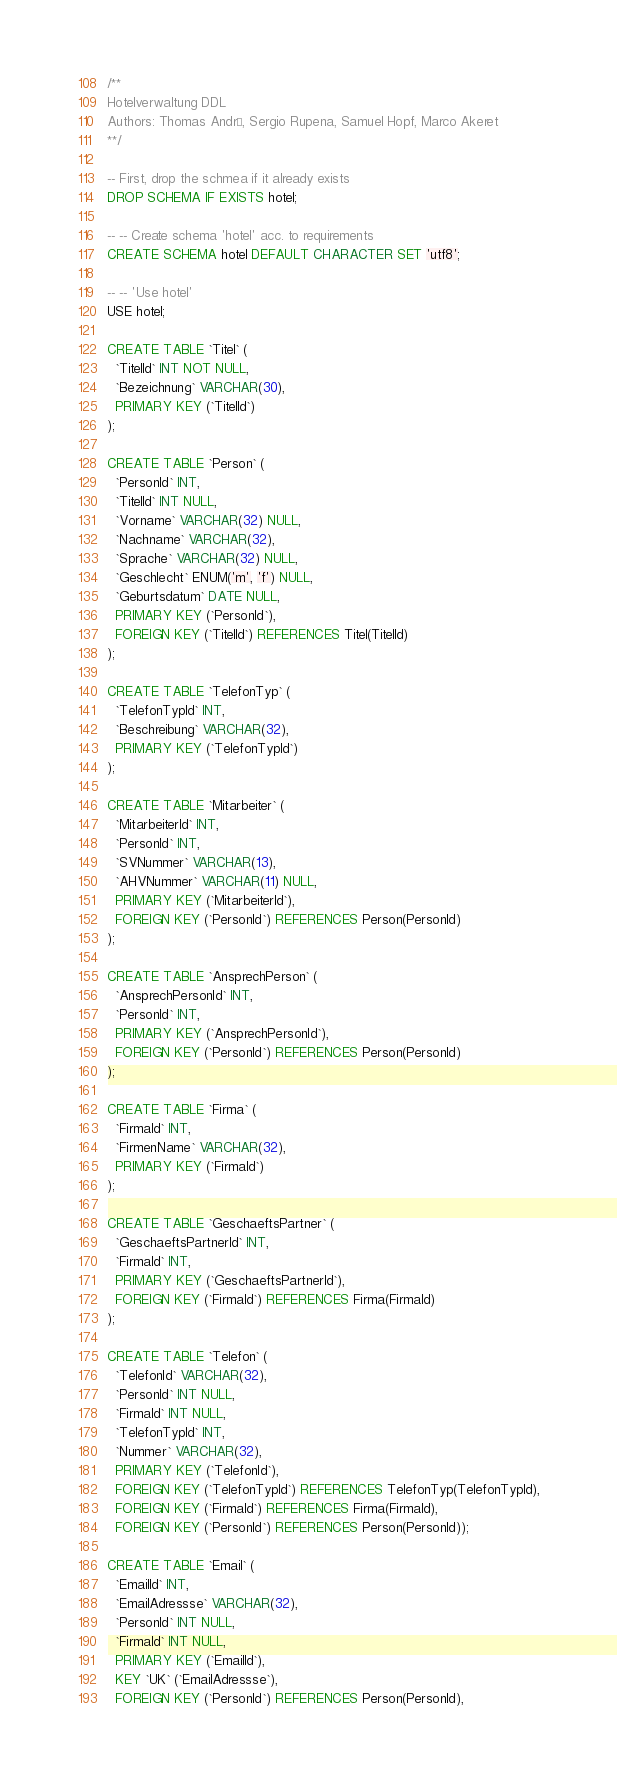<code> <loc_0><loc_0><loc_500><loc_500><_SQL_>/**
Hotelverwaltung DDL
Authors: Thomas André, Sergio Rupena, Samuel Hopf, Marco Akeret
**/

-- First, drop the schmea if it already exists
DROP SCHEMA IF EXISTS hotel;

-- -- Create schema 'hotel' acc. to requirements
CREATE SCHEMA hotel DEFAULT CHARACTER SET 'utf8';

-- -- 'Use hotel'
USE hotel;

CREATE TABLE `Titel` (
  `TitelId` INT NOT NULL,
  `Bezeichnung` VARCHAR(30),
  PRIMARY KEY (`TitelId`)
);

CREATE TABLE `Person` (
  `PersonId` INT,
  `TitelId` INT NULL,
  `Vorname` VARCHAR(32) NULL,
  `Nachname` VARCHAR(32),
  `Sprache` VARCHAR(32) NULL,
  `Geschlecht` ENUM('m', 'f') NULL,
  `Geburtsdatum` DATE NULL,
  PRIMARY KEY (`PersonId`),
  FOREIGN KEY (`TitelId`) REFERENCES Titel(TitelId) 
);

CREATE TABLE `TelefonTyp` (
  `TelefonTypId` INT,
  `Beschreibung` VARCHAR(32),
  PRIMARY KEY (`TelefonTypId`)
);

CREATE TABLE `Mitarbeiter` (
  `MitarbeiterId` INT,
  `PersonId` INT,
  `SVNummer` VARCHAR(13),
  `AHVNummer` VARCHAR(11) NULL,
  PRIMARY KEY (`MitarbeiterId`),
  FOREIGN KEY (`PersonId`) REFERENCES Person(PersonId)
);

CREATE TABLE `AnsprechPerson` (
  `AnsprechPersonId` INT,
  `PersonId` INT,
  PRIMARY KEY (`AnsprechPersonId`),
  FOREIGN KEY (`PersonId`) REFERENCES Person(PersonId)
);

CREATE TABLE `Firma` (
  `FirmaId` INT,
  `FirmenName` VARCHAR(32),
  PRIMARY KEY (`FirmaId`)
);

CREATE TABLE `GeschaeftsPartner` (
  `GeschaeftsPartnerId` INT,
  `FirmaId` INT,
  PRIMARY KEY (`GeschaeftsPartnerId`),
  FOREIGN KEY (`FirmaId`) REFERENCES Firma(FirmaId)
);

CREATE TABLE `Telefon` (
  `TelefonId` VARCHAR(32),
  `PersonId` INT NULL,
  `FirmaId` INT NULL,
  `TelefonTypId` INT,
  `Nummer` VARCHAR(32),
  PRIMARY KEY (`TelefonId`),
  FOREIGN KEY (`TelefonTypId`) REFERENCES TelefonTyp(TelefonTypId),
  FOREIGN KEY (`FirmaId`) REFERENCES Firma(FirmaId),
  FOREIGN KEY (`PersonId`) REFERENCES Person(PersonId));

CREATE TABLE `Email` (
  `EmailId` INT,
  `EmailAdressse` VARCHAR(32),
  `PersonId` INT NULL,
  `FirmaId` INT NULL,
  PRIMARY KEY (`EmailId`),
  KEY `UK` (`EmailAdressse`),
  FOREIGN KEY (`PersonId`) REFERENCES Person(PersonId),</code> 